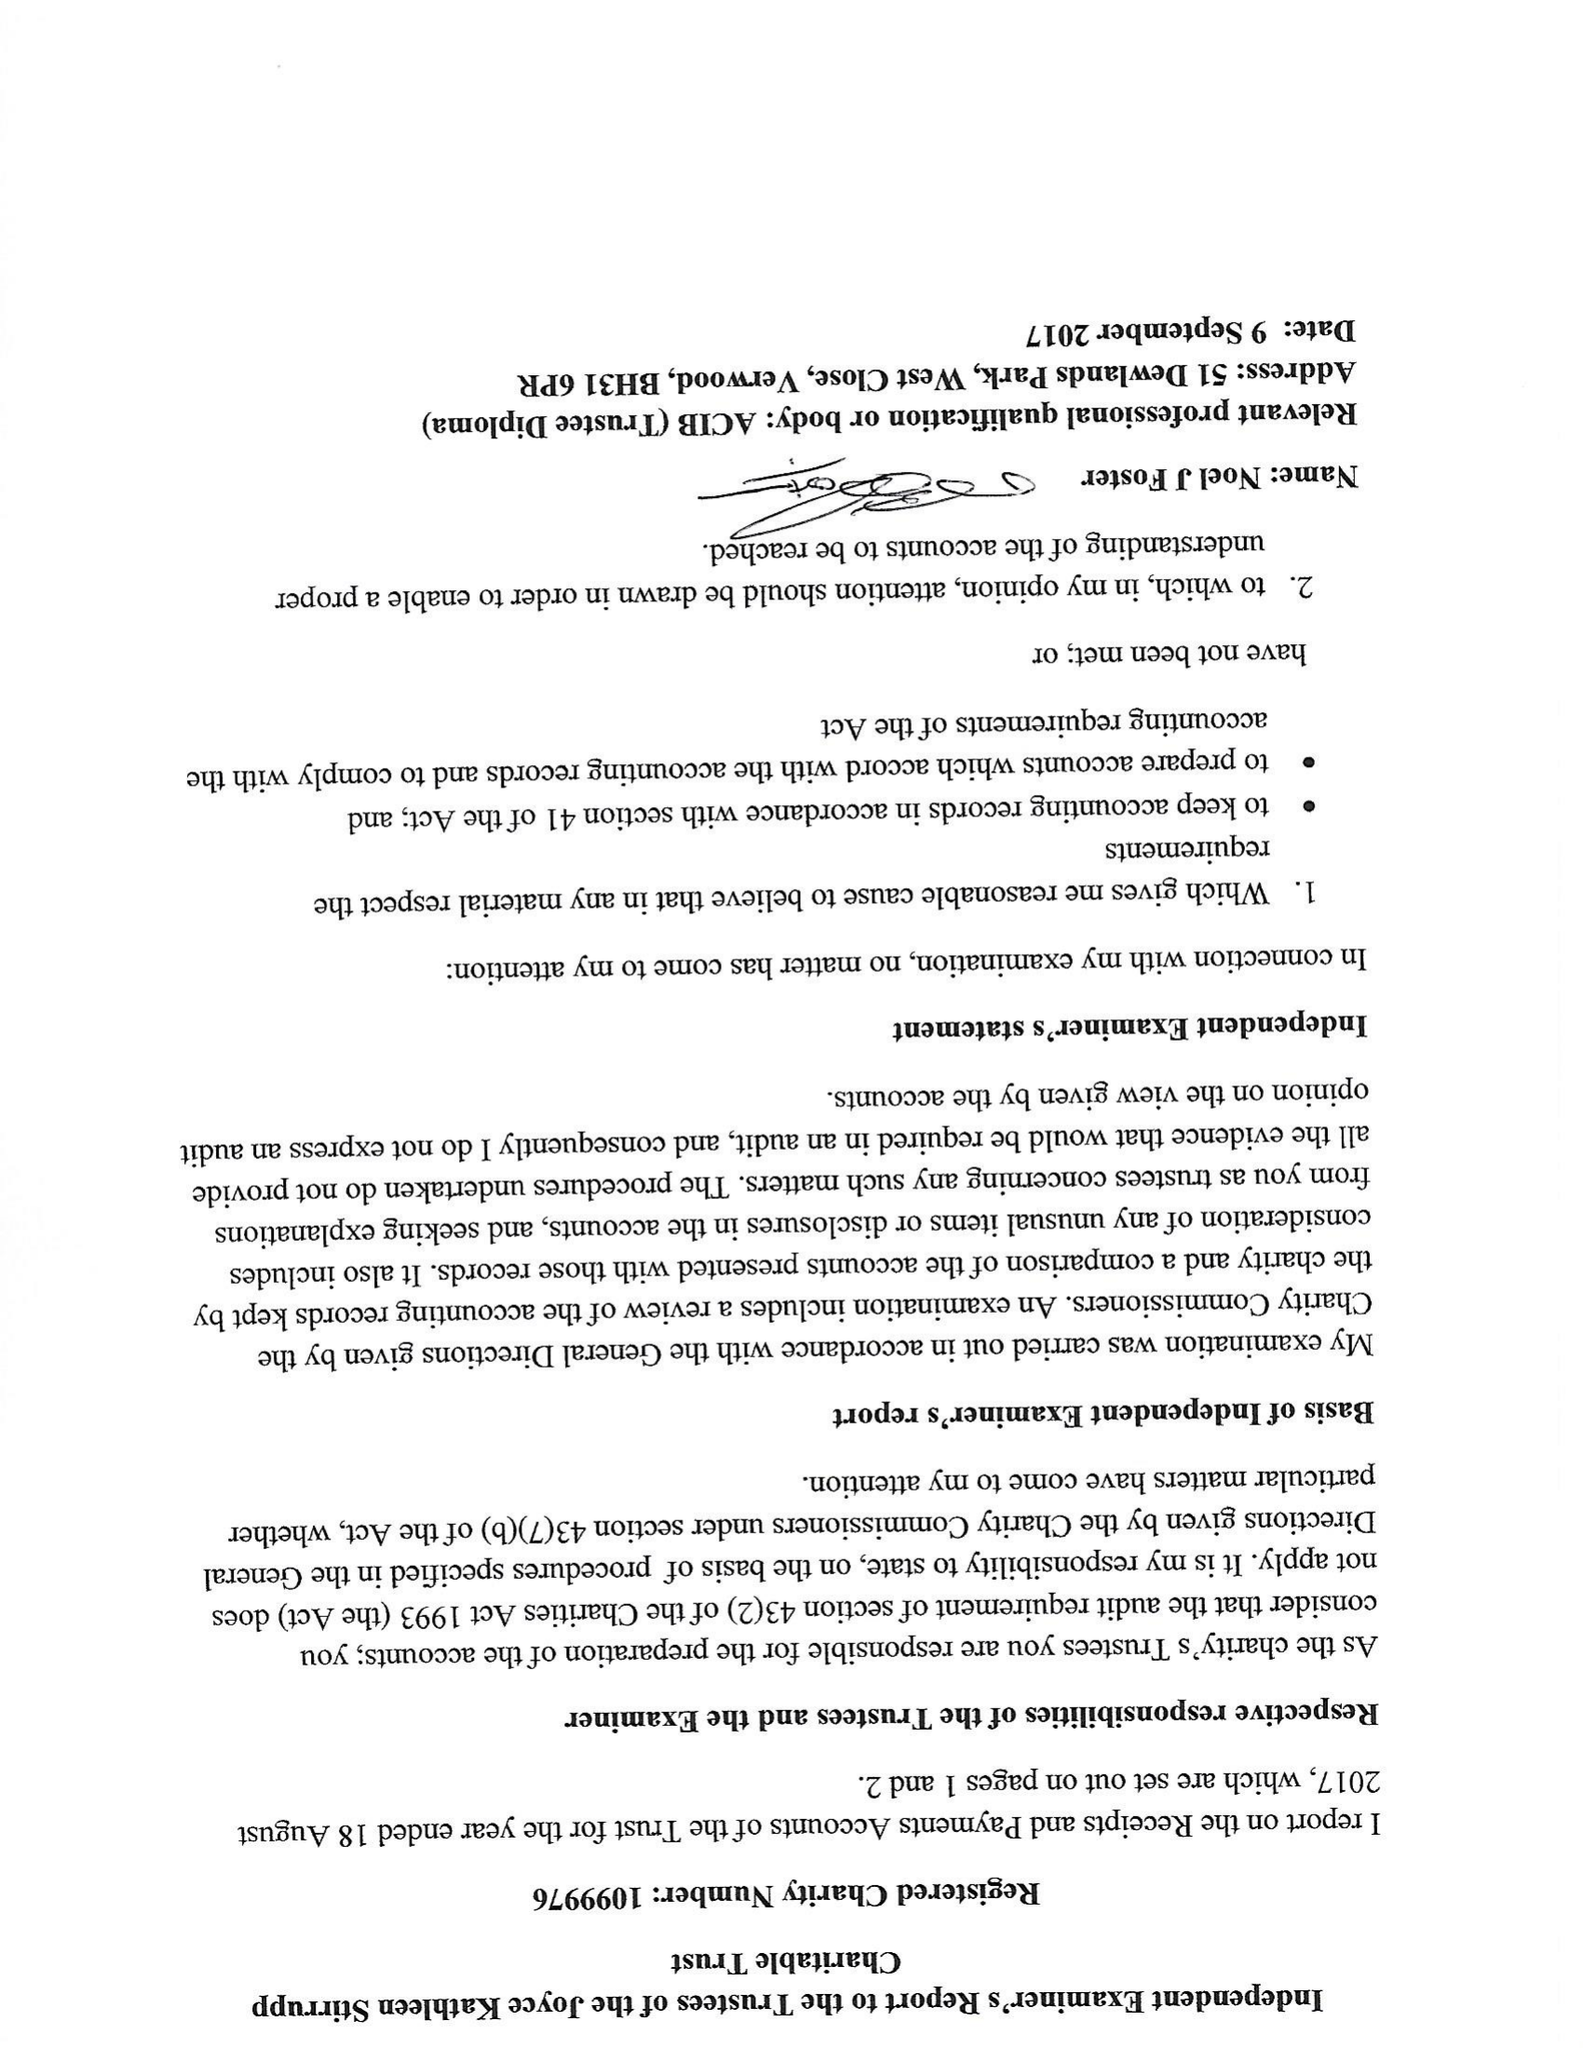What is the value for the address__street_line?
Answer the question using a single word or phrase. AVON STREET 